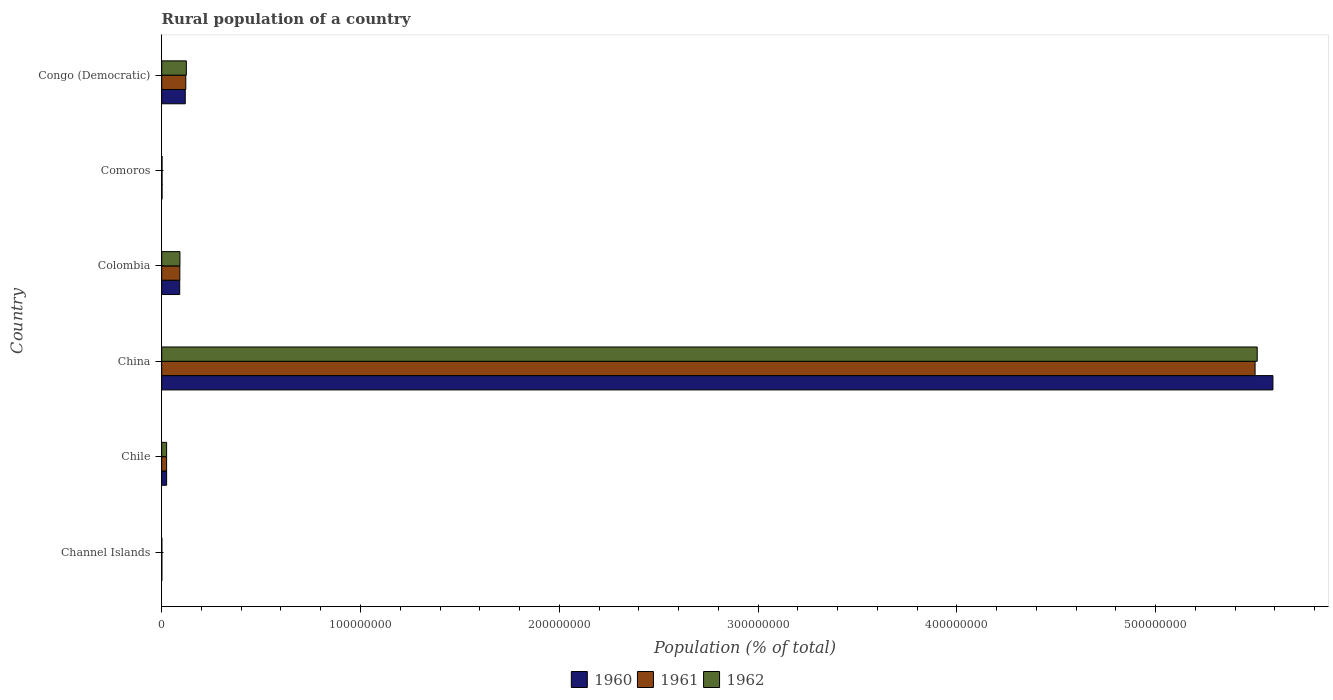How many different coloured bars are there?
Ensure brevity in your answer.  3. How many groups of bars are there?
Provide a succinct answer. 6. Are the number of bars per tick equal to the number of legend labels?
Offer a very short reply. Yes. How many bars are there on the 3rd tick from the top?
Your answer should be very brief. 3. What is the label of the 2nd group of bars from the top?
Offer a very short reply. Comoros. What is the rural population in 1962 in Chile?
Offer a very short reply. 2.46e+06. Across all countries, what is the maximum rural population in 1962?
Provide a short and direct response. 5.51e+08. Across all countries, what is the minimum rural population in 1960?
Keep it short and to the point. 6.71e+04. In which country was the rural population in 1962 maximum?
Give a very brief answer. China. In which country was the rural population in 1962 minimum?
Keep it short and to the point. Channel Islands. What is the total rural population in 1961 in the graph?
Ensure brevity in your answer.  5.74e+08. What is the difference between the rural population in 1961 in Chile and that in Comoros?
Provide a short and direct response. 2.30e+06. What is the difference between the rural population in 1962 in Congo (Democratic) and the rural population in 1960 in Colombia?
Keep it short and to the point. 3.33e+06. What is the average rural population in 1961 per country?
Ensure brevity in your answer.  9.57e+07. What is the difference between the rural population in 1961 and rural population in 1962 in Comoros?
Keep it short and to the point. -1074. What is the ratio of the rural population in 1961 in Comoros to that in Congo (Democratic)?
Make the answer very short. 0.01. Is the rural population in 1960 in Chile less than that in Congo (Democratic)?
Offer a very short reply. Yes. Is the difference between the rural population in 1961 in Colombia and Comoros greater than the difference between the rural population in 1962 in Colombia and Comoros?
Offer a terse response. No. What is the difference between the highest and the second highest rural population in 1961?
Ensure brevity in your answer.  5.38e+08. What is the difference between the highest and the lowest rural population in 1962?
Ensure brevity in your answer.  5.51e+08. What does the 1st bar from the bottom in Channel Islands represents?
Keep it short and to the point. 1960. Is it the case that in every country, the sum of the rural population in 1961 and rural population in 1962 is greater than the rural population in 1960?
Offer a terse response. Yes. How many countries are there in the graph?
Keep it short and to the point. 6. Where does the legend appear in the graph?
Ensure brevity in your answer.  Bottom center. What is the title of the graph?
Your response must be concise. Rural population of a country. What is the label or title of the X-axis?
Make the answer very short. Population (% of total). What is the Population (% of total) of 1960 in Channel Islands?
Give a very brief answer. 6.71e+04. What is the Population (% of total) in 1961 in Channel Islands?
Make the answer very short. 6.80e+04. What is the Population (% of total) of 1962 in Channel Islands?
Your answer should be compact. 6.89e+04. What is the Population (% of total) of 1960 in Chile?
Ensure brevity in your answer.  2.48e+06. What is the Population (% of total) in 1961 in Chile?
Ensure brevity in your answer.  2.47e+06. What is the Population (% of total) in 1962 in Chile?
Your answer should be compact. 2.46e+06. What is the Population (% of total) of 1960 in China?
Provide a succinct answer. 5.59e+08. What is the Population (% of total) of 1961 in China?
Ensure brevity in your answer.  5.50e+08. What is the Population (% of total) in 1962 in China?
Keep it short and to the point. 5.51e+08. What is the Population (% of total) in 1960 in Colombia?
Ensure brevity in your answer.  9.06e+06. What is the Population (% of total) of 1961 in Colombia?
Ensure brevity in your answer.  9.11e+06. What is the Population (% of total) in 1962 in Colombia?
Provide a short and direct response. 9.17e+06. What is the Population (% of total) in 1960 in Comoros?
Make the answer very short. 1.65e+05. What is the Population (% of total) in 1961 in Comoros?
Your response must be concise. 1.66e+05. What is the Population (% of total) of 1962 in Comoros?
Ensure brevity in your answer.  1.67e+05. What is the Population (% of total) of 1960 in Congo (Democratic)?
Offer a terse response. 1.18e+07. What is the Population (% of total) of 1961 in Congo (Democratic)?
Give a very brief answer. 1.21e+07. What is the Population (% of total) in 1962 in Congo (Democratic)?
Offer a very short reply. 1.24e+07. Across all countries, what is the maximum Population (% of total) of 1960?
Your response must be concise. 5.59e+08. Across all countries, what is the maximum Population (% of total) in 1961?
Offer a terse response. 5.50e+08. Across all countries, what is the maximum Population (% of total) in 1962?
Your answer should be very brief. 5.51e+08. Across all countries, what is the minimum Population (% of total) of 1960?
Provide a succinct answer. 6.71e+04. Across all countries, what is the minimum Population (% of total) of 1961?
Your response must be concise. 6.80e+04. Across all countries, what is the minimum Population (% of total) in 1962?
Offer a terse response. 6.89e+04. What is the total Population (% of total) of 1960 in the graph?
Give a very brief answer. 5.83e+08. What is the total Population (% of total) of 1961 in the graph?
Make the answer very short. 5.74e+08. What is the total Population (% of total) in 1962 in the graph?
Your answer should be very brief. 5.75e+08. What is the difference between the Population (% of total) of 1960 in Channel Islands and that in Chile?
Keep it short and to the point. -2.41e+06. What is the difference between the Population (% of total) of 1961 in Channel Islands and that in Chile?
Your answer should be very brief. -2.40e+06. What is the difference between the Population (% of total) in 1962 in Channel Islands and that in Chile?
Your answer should be very brief. -2.39e+06. What is the difference between the Population (% of total) in 1960 in Channel Islands and that in China?
Offer a terse response. -5.59e+08. What is the difference between the Population (% of total) of 1961 in Channel Islands and that in China?
Provide a succinct answer. -5.50e+08. What is the difference between the Population (% of total) in 1962 in Channel Islands and that in China?
Make the answer very short. -5.51e+08. What is the difference between the Population (% of total) of 1960 in Channel Islands and that in Colombia?
Offer a terse response. -8.99e+06. What is the difference between the Population (% of total) of 1961 in Channel Islands and that in Colombia?
Keep it short and to the point. -9.05e+06. What is the difference between the Population (% of total) in 1962 in Channel Islands and that in Colombia?
Offer a terse response. -9.10e+06. What is the difference between the Population (% of total) in 1960 in Channel Islands and that in Comoros?
Ensure brevity in your answer.  -9.80e+04. What is the difference between the Population (% of total) of 1961 in Channel Islands and that in Comoros?
Offer a terse response. -9.83e+04. What is the difference between the Population (% of total) in 1962 in Channel Islands and that in Comoros?
Ensure brevity in your answer.  -9.84e+04. What is the difference between the Population (% of total) in 1960 in Channel Islands and that in Congo (Democratic)?
Offer a very short reply. -1.18e+07. What is the difference between the Population (% of total) of 1961 in Channel Islands and that in Congo (Democratic)?
Give a very brief answer. -1.20e+07. What is the difference between the Population (% of total) of 1962 in Channel Islands and that in Congo (Democratic)?
Ensure brevity in your answer.  -1.23e+07. What is the difference between the Population (% of total) of 1960 in Chile and that in China?
Offer a terse response. -5.57e+08. What is the difference between the Population (% of total) in 1961 in Chile and that in China?
Provide a succinct answer. -5.48e+08. What is the difference between the Population (% of total) in 1962 in Chile and that in China?
Offer a very short reply. -5.49e+08. What is the difference between the Population (% of total) in 1960 in Chile and that in Colombia?
Your answer should be very brief. -6.58e+06. What is the difference between the Population (% of total) of 1961 in Chile and that in Colombia?
Your answer should be compact. -6.65e+06. What is the difference between the Population (% of total) of 1962 in Chile and that in Colombia?
Offer a terse response. -6.70e+06. What is the difference between the Population (% of total) of 1960 in Chile and that in Comoros?
Give a very brief answer. 2.31e+06. What is the difference between the Population (% of total) in 1961 in Chile and that in Comoros?
Make the answer very short. 2.30e+06. What is the difference between the Population (% of total) in 1962 in Chile and that in Comoros?
Keep it short and to the point. 2.29e+06. What is the difference between the Population (% of total) of 1960 in Chile and that in Congo (Democratic)?
Make the answer very short. -9.37e+06. What is the difference between the Population (% of total) in 1961 in Chile and that in Congo (Democratic)?
Provide a short and direct response. -9.65e+06. What is the difference between the Population (% of total) of 1962 in Chile and that in Congo (Democratic)?
Give a very brief answer. -9.93e+06. What is the difference between the Population (% of total) in 1960 in China and that in Colombia?
Provide a succinct answer. 5.50e+08. What is the difference between the Population (% of total) of 1961 in China and that in Colombia?
Your answer should be very brief. 5.41e+08. What is the difference between the Population (% of total) in 1962 in China and that in Colombia?
Offer a very short reply. 5.42e+08. What is the difference between the Population (% of total) of 1960 in China and that in Comoros?
Offer a very short reply. 5.59e+08. What is the difference between the Population (% of total) in 1961 in China and that in Comoros?
Make the answer very short. 5.50e+08. What is the difference between the Population (% of total) of 1962 in China and that in Comoros?
Your response must be concise. 5.51e+08. What is the difference between the Population (% of total) of 1960 in China and that in Congo (Democratic)?
Offer a very short reply. 5.47e+08. What is the difference between the Population (% of total) in 1961 in China and that in Congo (Democratic)?
Your answer should be very brief. 5.38e+08. What is the difference between the Population (% of total) in 1962 in China and that in Congo (Democratic)?
Offer a very short reply. 5.39e+08. What is the difference between the Population (% of total) of 1960 in Colombia and that in Comoros?
Provide a short and direct response. 8.89e+06. What is the difference between the Population (% of total) in 1961 in Colombia and that in Comoros?
Keep it short and to the point. 8.95e+06. What is the difference between the Population (% of total) in 1962 in Colombia and that in Comoros?
Your answer should be very brief. 9.00e+06. What is the difference between the Population (% of total) of 1960 in Colombia and that in Congo (Democratic)?
Your answer should be compact. -2.79e+06. What is the difference between the Population (% of total) of 1961 in Colombia and that in Congo (Democratic)?
Offer a terse response. -3.00e+06. What is the difference between the Population (% of total) in 1962 in Colombia and that in Congo (Democratic)?
Ensure brevity in your answer.  -3.23e+06. What is the difference between the Population (% of total) of 1960 in Comoros and that in Congo (Democratic)?
Give a very brief answer. -1.17e+07. What is the difference between the Population (% of total) in 1961 in Comoros and that in Congo (Democratic)?
Your response must be concise. -1.19e+07. What is the difference between the Population (% of total) in 1962 in Comoros and that in Congo (Democratic)?
Give a very brief answer. -1.22e+07. What is the difference between the Population (% of total) in 1960 in Channel Islands and the Population (% of total) in 1961 in Chile?
Provide a short and direct response. -2.40e+06. What is the difference between the Population (% of total) in 1960 in Channel Islands and the Population (% of total) in 1962 in Chile?
Provide a succinct answer. -2.39e+06. What is the difference between the Population (% of total) in 1961 in Channel Islands and the Population (% of total) in 1962 in Chile?
Offer a very short reply. -2.39e+06. What is the difference between the Population (% of total) of 1960 in Channel Islands and the Population (% of total) of 1961 in China?
Your response must be concise. -5.50e+08. What is the difference between the Population (% of total) in 1960 in Channel Islands and the Population (% of total) in 1962 in China?
Keep it short and to the point. -5.51e+08. What is the difference between the Population (% of total) in 1961 in Channel Islands and the Population (% of total) in 1962 in China?
Give a very brief answer. -5.51e+08. What is the difference between the Population (% of total) in 1960 in Channel Islands and the Population (% of total) in 1961 in Colombia?
Ensure brevity in your answer.  -9.05e+06. What is the difference between the Population (% of total) of 1960 in Channel Islands and the Population (% of total) of 1962 in Colombia?
Keep it short and to the point. -9.10e+06. What is the difference between the Population (% of total) in 1961 in Channel Islands and the Population (% of total) in 1962 in Colombia?
Your answer should be compact. -9.10e+06. What is the difference between the Population (% of total) in 1960 in Channel Islands and the Population (% of total) in 1961 in Comoros?
Your response must be concise. -9.91e+04. What is the difference between the Population (% of total) of 1960 in Channel Islands and the Population (% of total) of 1962 in Comoros?
Your answer should be very brief. -1.00e+05. What is the difference between the Population (% of total) in 1961 in Channel Islands and the Population (% of total) in 1962 in Comoros?
Offer a very short reply. -9.93e+04. What is the difference between the Population (% of total) of 1960 in Channel Islands and the Population (% of total) of 1961 in Congo (Democratic)?
Give a very brief answer. -1.20e+07. What is the difference between the Population (% of total) in 1960 in Channel Islands and the Population (% of total) in 1962 in Congo (Democratic)?
Your response must be concise. -1.23e+07. What is the difference between the Population (% of total) in 1961 in Channel Islands and the Population (% of total) in 1962 in Congo (Democratic)?
Your answer should be compact. -1.23e+07. What is the difference between the Population (% of total) of 1960 in Chile and the Population (% of total) of 1961 in China?
Your answer should be very brief. -5.48e+08. What is the difference between the Population (% of total) in 1960 in Chile and the Population (% of total) in 1962 in China?
Offer a terse response. -5.49e+08. What is the difference between the Population (% of total) of 1961 in Chile and the Population (% of total) of 1962 in China?
Your answer should be very brief. -5.49e+08. What is the difference between the Population (% of total) in 1960 in Chile and the Population (% of total) in 1961 in Colombia?
Offer a very short reply. -6.64e+06. What is the difference between the Population (% of total) of 1960 in Chile and the Population (% of total) of 1962 in Colombia?
Your response must be concise. -6.69e+06. What is the difference between the Population (% of total) of 1961 in Chile and the Population (% of total) of 1962 in Colombia?
Provide a short and direct response. -6.70e+06. What is the difference between the Population (% of total) in 1960 in Chile and the Population (% of total) in 1961 in Comoros?
Give a very brief answer. 2.31e+06. What is the difference between the Population (% of total) of 1960 in Chile and the Population (% of total) of 1962 in Comoros?
Your answer should be compact. 2.31e+06. What is the difference between the Population (% of total) of 1961 in Chile and the Population (% of total) of 1962 in Comoros?
Ensure brevity in your answer.  2.30e+06. What is the difference between the Population (% of total) in 1960 in Chile and the Population (% of total) in 1961 in Congo (Democratic)?
Provide a succinct answer. -9.64e+06. What is the difference between the Population (% of total) in 1960 in Chile and the Population (% of total) in 1962 in Congo (Democratic)?
Provide a short and direct response. -9.92e+06. What is the difference between the Population (% of total) in 1961 in Chile and the Population (% of total) in 1962 in Congo (Democratic)?
Your response must be concise. -9.92e+06. What is the difference between the Population (% of total) in 1960 in China and the Population (% of total) in 1961 in Colombia?
Make the answer very short. 5.50e+08. What is the difference between the Population (% of total) in 1960 in China and the Population (% of total) in 1962 in Colombia?
Keep it short and to the point. 5.50e+08. What is the difference between the Population (% of total) of 1961 in China and the Population (% of total) of 1962 in Colombia?
Your response must be concise. 5.41e+08. What is the difference between the Population (% of total) of 1960 in China and the Population (% of total) of 1961 in Comoros?
Keep it short and to the point. 5.59e+08. What is the difference between the Population (% of total) in 1960 in China and the Population (% of total) in 1962 in Comoros?
Provide a short and direct response. 5.59e+08. What is the difference between the Population (% of total) of 1961 in China and the Population (% of total) of 1962 in Comoros?
Offer a terse response. 5.50e+08. What is the difference between the Population (% of total) in 1960 in China and the Population (% of total) in 1961 in Congo (Democratic)?
Offer a very short reply. 5.47e+08. What is the difference between the Population (% of total) of 1960 in China and the Population (% of total) of 1962 in Congo (Democratic)?
Provide a short and direct response. 5.47e+08. What is the difference between the Population (% of total) of 1961 in China and the Population (% of total) of 1962 in Congo (Democratic)?
Provide a succinct answer. 5.38e+08. What is the difference between the Population (% of total) in 1960 in Colombia and the Population (% of total) in 1961 in Comoros?
Give a very brief answer. 8.89e+06. What is the difference between the Population (% of total) in 1960 in Colombia and the Population (% of total) in 1962 in Comoros?
Give a very brief answer. 8.89e+06. What is the difference between the Population (% of total) of 1961 in Colombia and the Population (% of total) of 1962 in Comoros?
Make the answer very short. 8.95e+06. What is the difference between the Population (% of total) in 1960 in Colombia and the Population (% of total) in 1961 in Congo (Democratic)?
Give a very brief answer. -3.06e+06. What is the difference between the Population (% of total) in 1960 in Colombia and the Population (% of total) in 1962 in Congo (Democratic)?
Make the answer very short. -3.33e+06. What is the difference between the Population (% of total) in 1961 in Colombia and the Population (% of total) in 1962 in Congo (Democratic)?
Provide a succinct answer. -3.28e+06. What is the difference between the Population (% of total) of 1960 in Comoros and the Population (% of total) of 1961 in Congo (Democratic)?
Offer a very short reply. -1.20e+07. What is the difference between the Population (% of total) in 1960 in Comoros and the Population (% of total) in 1962 in Congo (Democratic)?
Offer a very short reply. -1.22e+07. What is the difference between the Population (% of total) in 1961 in Comoros and the Population (% of total) in 1962 in Congo (Democratic)?
Offer a terse response. -1.22e+07. What is the average Population (% of total) of 1960 per country?
Offer a terse response. 9.71e+07. What is the average Population (% of total) of 1961 per country?
Provide a short and direct response. 9.57e+07. What is the average Population (% of total) of 1962 per country?
Ensure brevity in your answer.  9.59e+07. What is the difference between the Population (% of total) in 1960 and Population (% of total) in 1961 in Channel Islands?
Offer a very short reply. -892. What is the difference between the Population (% of total) of 1960 and Population (% of total) of 1962 in Channel Islands?
Provide a succinct answer. -1841. What is the difference between the Population (% of total) of 1961 and Population (% of total) of 1962 in Channel Islands?
Offer a terse response. -949. What is the difference between the Population (% of total) of 1960 and Population (% of total) of 1961 in Chile?
Give a very brief answer. 7686. What is the difference between the Population (% of total) in 1960 and Population (% of total) in 1962 in Chile?
Ensure brevity in your answer.  1.35e+04. What is the difference between the Population (% of total) in 1961 and Population (% of total) in 1962 in Chile?
Keep it short and to the point. 5800. What is the difference between the Population (% of total) of 1960 and Population (% of total) of 1961 in China?
Keep it short and to the point. 8.98e+06. What is the difference between the Population (% of total) of 1960 and Population (% of total) of 1962 in China?
Your answer should be very brief. 7.90e+06. What is the difference between the Population (% of total) of 1961 and Population (% of total) of 1962 in China?
Offer a very short reply. -1.08e+06. What is the difference between the Population (% of total) in 1960 and Population (% of total) in 1961 in Colombia?
Keep it short and to the point. -5.61e+04. What is the difference between the Population (% of total) in 1960 and Population (% of total) in 1962 in Colombia?
Offer a terse response. -1.06e+05. What is the difference between the Population (% of total) of 1961 and Population (% of total) of 1962 in Colombia?
Provide a short and direct response. -5.03e+04. What is the difference between the Population (% of total) in 1960 and Population (% of total) in 1961 in Comoros?
Your answer should be compact. -1179. What is the difference between the Population (% of total) of 1960 and Population (% of total) of 1962 in Comoros?
Ensure brevity in your answer.  -2253. What is the difference between the Population (% of total) in 1961 and Population (% of total) in 1962 in Comoros?
Provide a short and direct response. -1074. What is the difference between the Population (% of total) in 1960 and Population (% of total) in 1961 in Congo (Democratic)?
Ensure brevity in your answer.  -2.68e+05. What is the difference between the Population (% of total) of 1960 and Population (% of total) of 1962 in Congo (Democratic)?
Provide a succinct answer. -5.44e+05. What is the difference between the Population (% of total) of 1961 and Population (% of total) of 1962 in Congo (Democratic)?
Ensure brevity in your answer.  -2.76e+05. What is the ratio of the Population (% of total) of 1960 in Channel Islands to that in Chile?
Offer a terse response. 0.03. What is the ratio of the Population (% of total) of 1961 in Channel Islands to that in Chile?
Offer a terse response. 0.03. What is the ratio of the Population (% of total) of 1962 in Channel Islands to that in Chile?
Your response must be concise. 0.03. What is the ratio of the Population (% of total) in 1961 in Channel Islands to that in China?
Your answer should be very brief. 0. What is the ratio of the Population (% of total) in 1962 in Channel Islands to that in China?
Give a very brief answer. 0. What is the ratio of the Population (% of total) in 1960 in Channel Islands to that in Colombia?
Your response must be concise. 0.01. What is the ratio of the Population (% of total) of 1961 in Channel Islands to that in Colombia?
Provide a short and direct response. 0.01. What is the ratio of the Population (% of total) in 1962 in Channel Islands to that in Colombia?
Keep it short and to the point. 0.01. What is the ratio of the Population (% of total) of 1960 in Channel Islands to that in Comoros?
Provide a short and direct response. 0.41. What is the ratio of the Population (% of total) in 1961 in Channel Islands to that in Comoros?
Your response must be concise. 0.41. What is the ratio of the Population (% of total) in 1962 in Channel Islands to that in Comoros?
Ensure brevity in your answer.  0.41. What is the ratio of the Population (% of total) in 1960 in Channel Islands to that in Congo (Democratic)?
Your response must be concise. 0.01. What is the ratio of the Population (% of total) in 1961 in Channel Islands to that in Congo (Democratic)?
Offer a terse response. 0.01. What is the ratio of the Population (% of total) of 1962 in Channel Islands to that in Congo (Democratic)?
Offer a very short reply. 0.01. What is the ratio of the Population (% of total) of 1960 in Chile to that in China?
Provide a succinct answer. 0. What is the ratio of the Population (% of total) of 1961 in Chile to that in China?
Your answer should be very brief. 0. What is the ratio of the Population (% of total) in 1962 in Chile to that in China?
Your answer should be compact. 0. What is the ratio of the Population (% of total) of 1960 in Chile to that in Colombia?
Provide a succinct answer. 0.27. What is the ratio of the Population (% of total) in 1961 in Chile to that in Colombia?
Provide a succinct answer. 0.27. What is the ratio of the Population (% of total) in 1962 in Chile to that in Colombia?
Make the answer very short. 0.27. What is the ratio of the Population (% of total) of 1960 in Chile to that in Comoros?
Your answer should be very brief. 15. What is the ratio of the Population (% of total) in 1961 in Chile to that in Comoros?
Offer a very short reply. 14.84. What is the ratio of the Population (% of total) of 1962 in Chile to that in Comoros?
Ensure brevity in your answer.  14.71. What is the ratio of the Population (% of total) of 1960 in Chile to that in Congo (Democratic)?
Make the answer very short. 0.21. What is the ratio of the Population (% of total) in 1961 in Chile to that in Congo (Democratic)?
Offer a very short reply. 0.2. What is the ratio of the Population (% of total) in 1962 in Chile to that in Congo (Democratic)?
Make the answer very short. 0.2. What is the ratio of the Population (% of total) of 1960 in China to that in Colombia?
Ensure brevity in your answer.  61.71. What is the ratio of the Population (% of total) in 1961 in China to that in Colombia?
Ensure brevity in your answer.  60.34. What is the ratio of the Population (% of total) of 1962 in China to that in Colombia?
Your answer should be compact. 60.13. What is the ratio of the Population (% of total) in 1960 in China to that in Comoros?
Offer a very short reply. 3386.88. What is the ratio of the Population (% of total) of 1961 in China to that in Comoros?
Make the answer very short. 3308.82. What is the ratio of the Population (% of total) in 1962 in China to that in Comoros?
Your response must be concise. 3294.05. What is the ratio of the Population (% of total) of 1960 in China to that in Congo (Democratic)?
Provide a succinct answer. 47.18. What is the ratio of the Population (% of total) in 1961 in China to that in Congo (Democratic)?
Your answer should be very brief. 45.4. What is the ratio of the Population (% of total) in 1962 in China to that in Congo (Democratic)?
Your answer should be compact. 44.47. What is the ratio of the Population (% of total) of 1960 in Colombia to that in Comoros?
Give a very brief answer. 54.89. What is the ratio of the Population (% of total) in 1961 in Colombia to that in Comoros?
Your answer should be compact. 54.84. What is the ratio of the Population (% of total) of 1962 in Colombia to that in Comoros?
Make the answer very short. 54.78. What is the ratio of the Population (% of total) of 1960 in Colombia to that in Congo (Democratic)?
Ensure brevity in your answer.  0.76. What is the ratio of the Population (% of total) of 1961 in Colombia to that in Congo (Democratic)?
Ensure brevity in your answer.  0.75. What is the ratio of the Population (% of total) of 1962 in Colombia to that in Congo (Democratic)?
Offer a very short reply. 0.74. What is the ratio of the Population (% of total) of 1960 in Comoros to that in Congo (Democratic)?
Provide a short and direct response. 0.01. What is the ratio of the Population (% of total) of 1961 in Comoros to that in Congo (Democratic)?
Your answer should be compact. 0.01. What is the ratio of the Population (% of total) of 1962 in Comoros to that in Congo (Democratic)?
Keep it short and to the point. 0.01. What is the difference between the highest and the second highest Population (% of total) of 1960?
Provide a short and direct response. 5.47e+08. What is the difference between the highest and the second highest Population (% of total) in 1961?
Your response must be concise. 5.38e+08. What is the difference between the highest and the second highest Population (% of total) of 1962?
Provide a succinct answer. 5.39e+08. What is the difference between the highest and the lowest Population (% of total) of 1960?
Offer a very short reply. 5.59e+08. What is the difference between the highest and the lowest Population (% of total) in 1961?
Make the answer very short. 5.50e+08. What is the difference between the highest and the lowest Population (% of total) of 1962?
Give a very brief answer. 5.51e+08. 